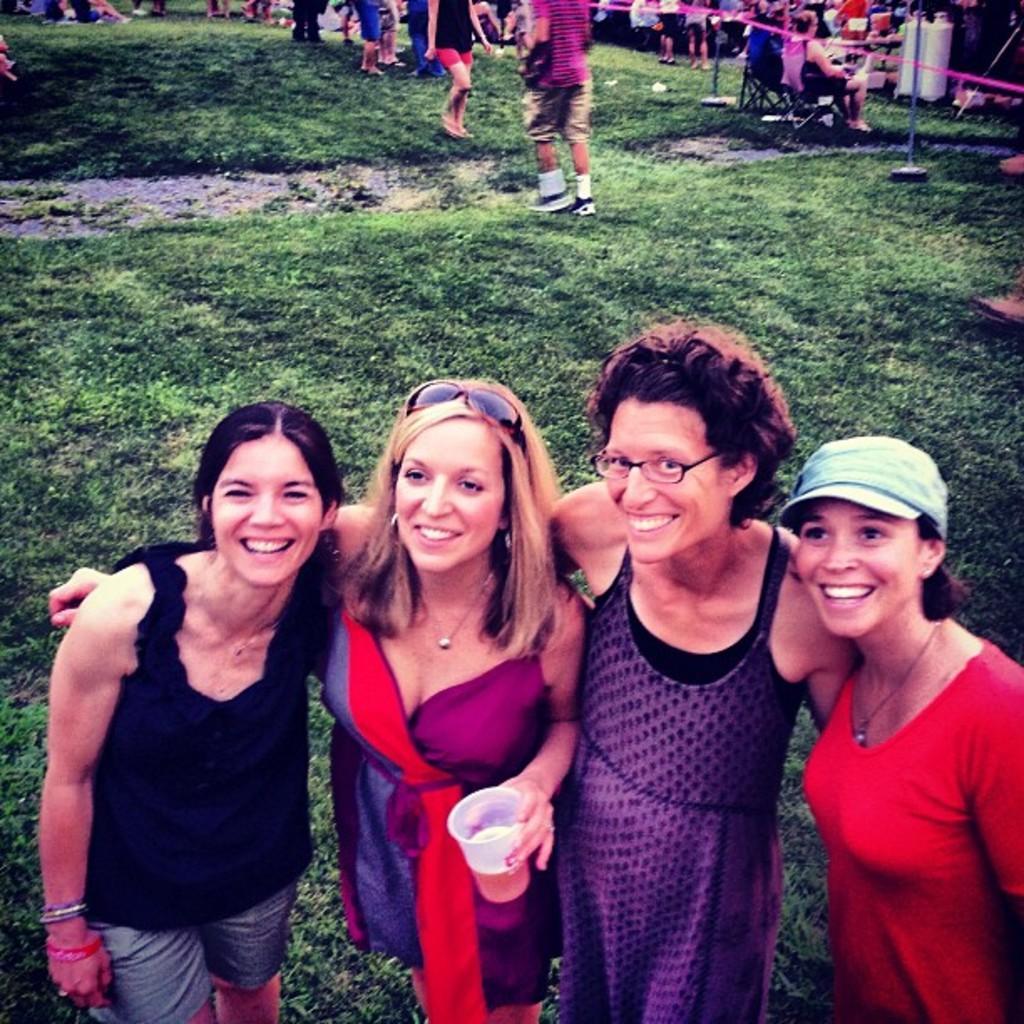Describe this image in one or two sentences. There are four ladies standing. One lady is holding a glass. Lady on the right is wearing a cap. Next to her a lady is wearing specs. Another lady is keeping goggles on the head. On the ground there is grass. In the back there are many people. Few are sitting on chairs. 